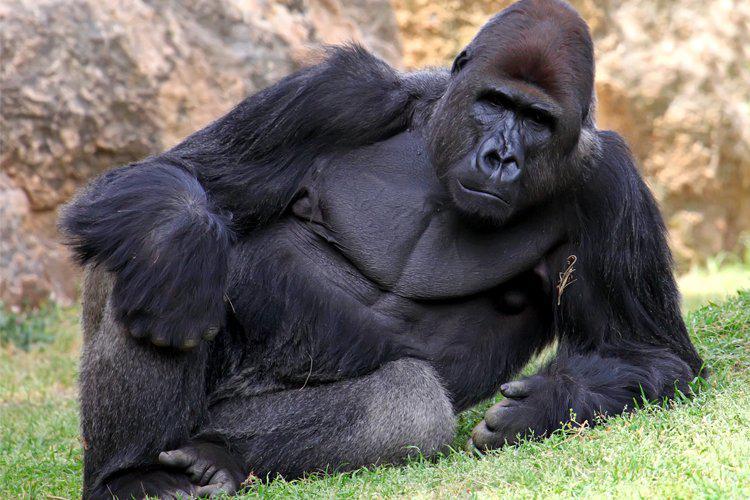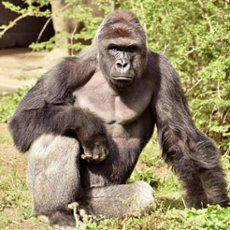The first image is the image on the left, the second image is the image on the right. Considering the images on both sides, is "In each image, two male gorillas stand facing each other, with one gorilla baring its fangs with wide-open mouth." valid? Answer yes or no. No. The first image is the image on the left, the second image is the image on the right. Assess this claim about the two images: "Two animals are standing up in each of the images.". Correct or not? Answer yes or no. No. 